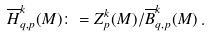<formula> <loc_0><loc_0><loc_500><loc_500>\overline { H } _ { q , p } ^ { k } ( M ) \colon = Z _ { p } ^ { k } ( M ) / \overline { B } _ { q , p } ^ { k } ( M ) \, .</formula> 